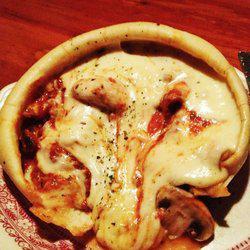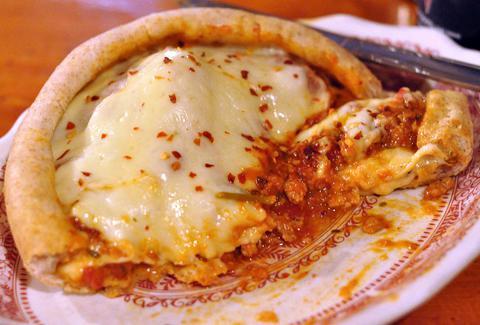The first image is the image on the left, the second image is the image on the right. Evaluate the accuracy of this statement regarding the images: "Each image shows exactly one item with melted cheese surrounded by a round crust on a plate with ornate dark red trim.". Is it true? Answer yes or no. Yes. 